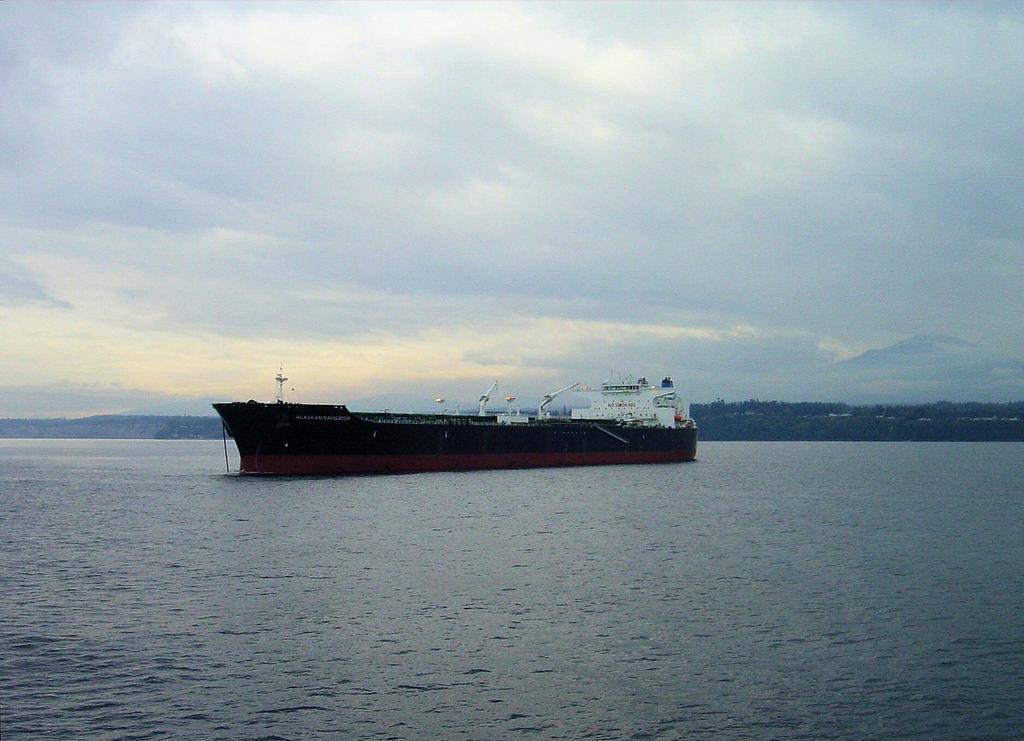What can be seen in the sky in the image? The sky is visible in the image, and clouds are present. What type of landscape is depicted in the image? The image features hills and trees. What is the main subject in the image? There is a ship in the image. What is the setting of the image? Water is visible in the image. What type of dogs can be seen playing near the dock in the image? There is no dock or dogs present in the image. What does the image smell like? The image does not have a smell, as it is a visual representation. 